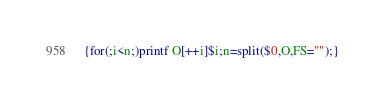<code> <loc_0><loc_0><loc_500><loc_500><_Awk_>{for(;i<n;)printf O[++i]$i;n=split($0,O,FS="");}</code> 